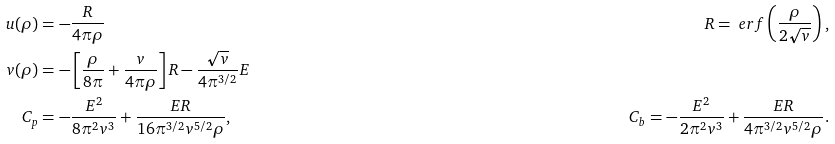<formula> <loc_0><loc_0><loc_500><loc_500>u ( \rho ) & = - \frac { R } { 4 \pi \rho } & R = \ e r f \left ( \frac { \rho } { 2 \sqrt { v } } \right ) , \\ v ( \rho ) & = - \left [ \frac { \rho } { 8 \pi } + \frac { v } { 4 \pi \rho } \right ] R - \frac { \sqrt { v } } { 4 \pi ^ { 3 / 2 } } E \\ C _ { p } & = - \frac { E ^ { 2 } } { 8 \pi ^ { 2 } v ^ { 3 } } + \frac { E R } { 1 6 \pi ^ { 3 / 2 } v ^ { 5 / 2 } \rho } , & C _ { b } = - \frac { E ^ { 2 } } { 2 \pi ^ { 2 } v ^ { 3 } } + \frac { E R } { 4 \pi ^ { 3 / 2 } v ^ { 5 / 2 } \rho } .</formula> 